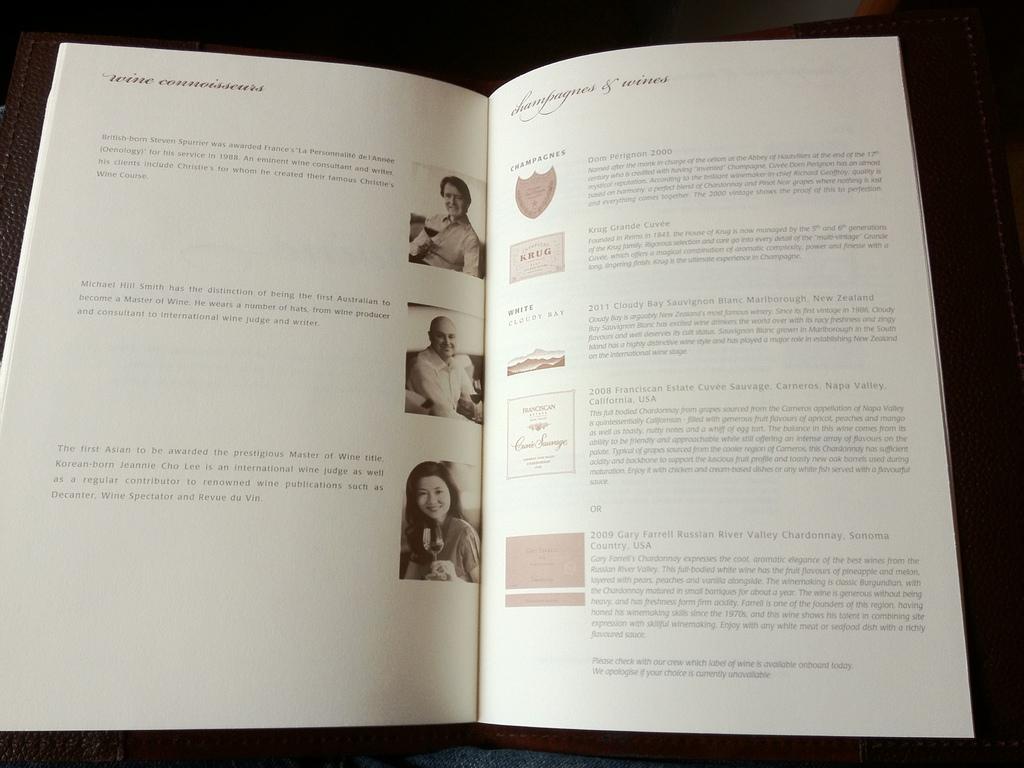What is the subject of the left page?
Give a very brief answer. Wine connoisseurs. 